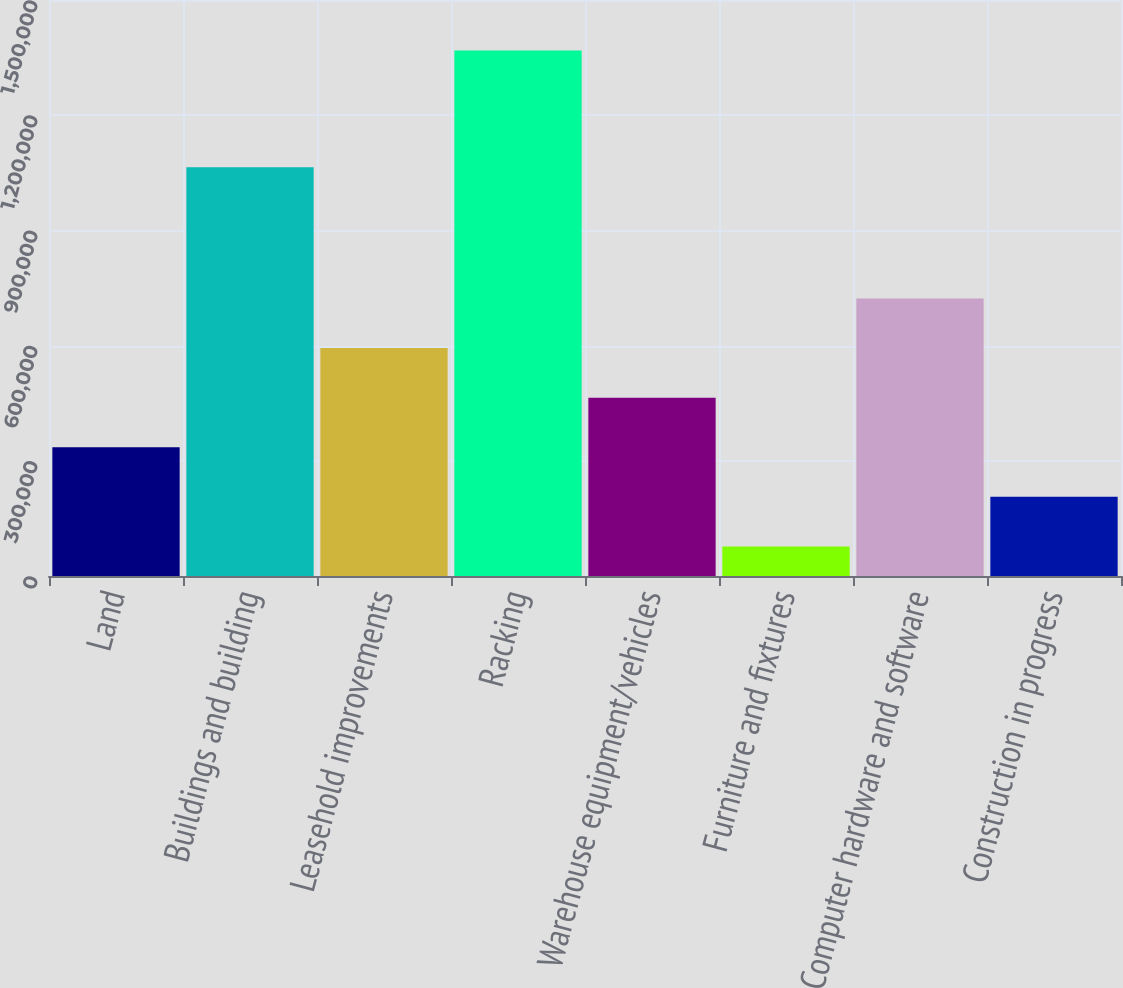Convert chart. <chart><loc_0><loc_0><loc_500><loc_500><bar_chart><fcel>Land<fcel>Buildings and building<fcel>Leasehold improvements<fcel>Racking<fcel>Warehouse equipment/vehicles<fcel>Furniture and fixtures<fcel>Computer hardware and software<fcel>Construction in progress<nl><fcel>335220<fcel>1.06448e+06<fcel>593470<fcel>1.36822e+06<fcel>464345<fcel>76971<fcel>722594<fcel>206096<nl></chart> 